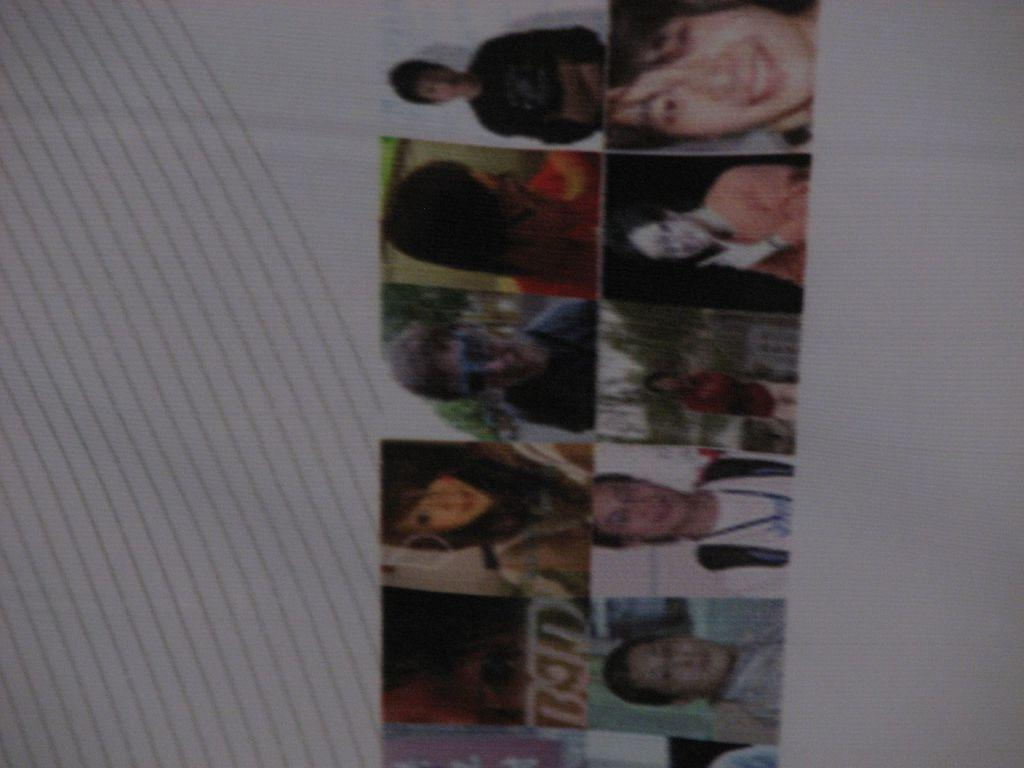What is the main subject of the image? The main subject of the image is photos of different people. What is the color of the surface on which the photos are placed? The photos are on a white surface. How many geese are present in the garden in the image? There is no garden or geese present in the image; it features photos of different people on a white surface. 